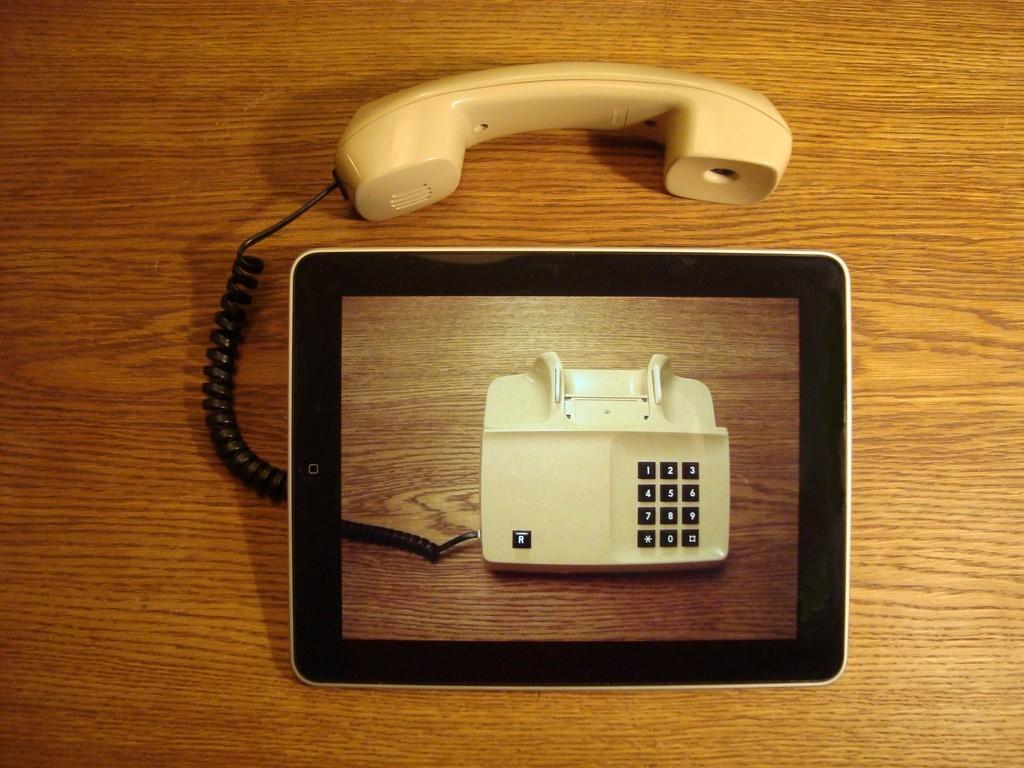Could you give a brief overview of what you see in this image? In this picture I can see a tab and a telephone in the middle. 